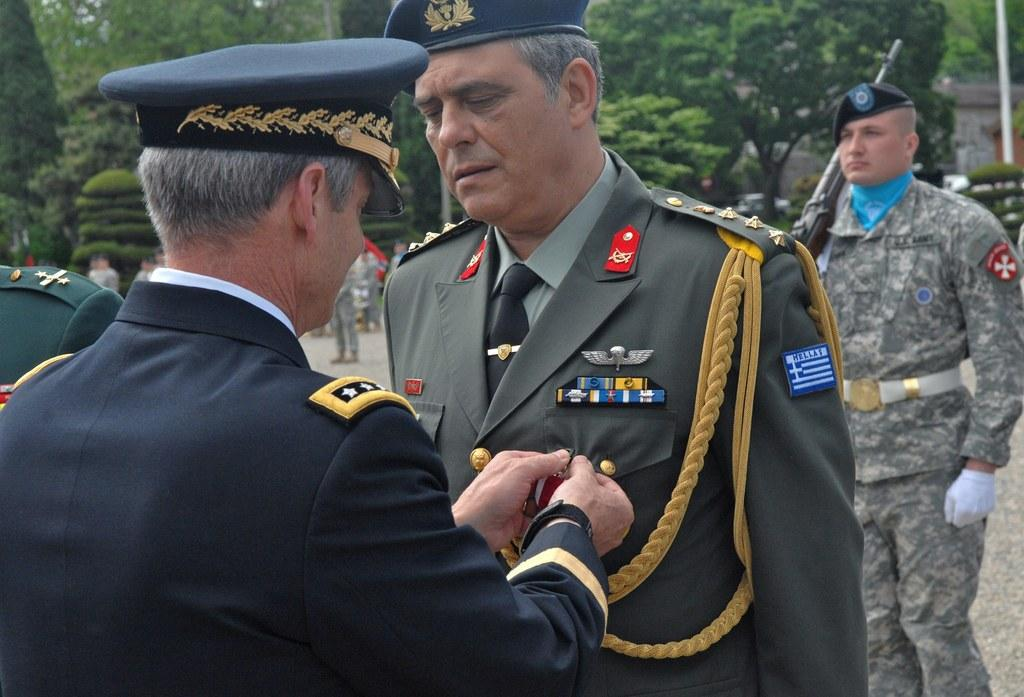How many people are in the background of the image? There are two persons in the background of the image. What type of natural vegetation can be seen in the image? There are trees visible in the image. What object is located on the right side of the image? There is a pole on the right side of the image. Reasoning: Let' Let's think step by step in order to produce the conversation. We start by identifying the number of people in the background, which is two. Then, we describe the natural vegetation present in the image, which are trees. Finally, we mention the pole located on the right side of the image. Each question is designed to elicit a specific detail about the image that is known from the provided facts. Absurd Question/Answer: How many legs does the island have in the image? There is no island present in the image, so it is not possible to determine how many legs it might have. How many legs does the island have in the image? There is no island present in the image, so it is not possible to determine how many legs it might have. 